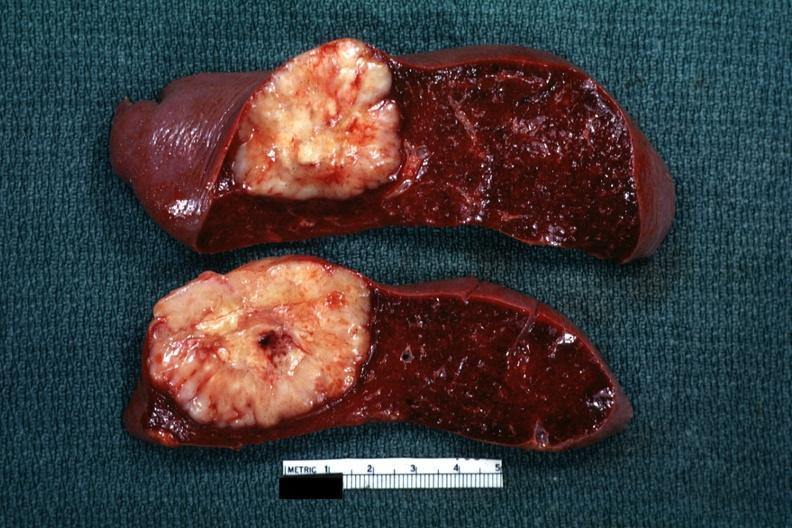s hematologic present?
Answer the question using a single word or phrase. Yes 